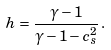<formula> <loc_0><loc_0><loc_500><loc_500>h = \frac { \gamma - 1 } { \gamma - 1 - c _ { s } ^ { 2 } } \, .</formula> 